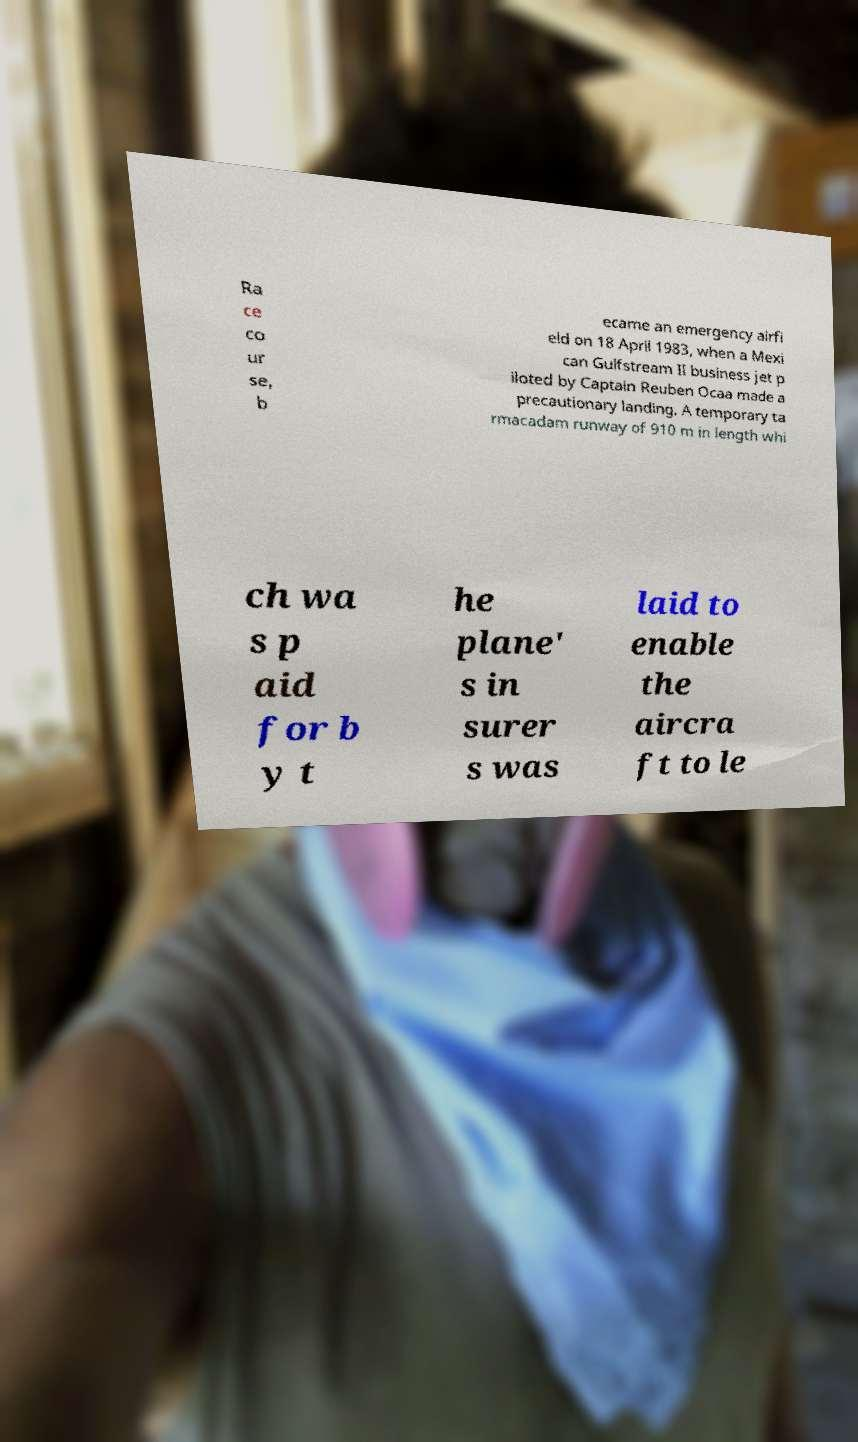What messages or text are displayed in this image? I need them in a readable, typed format. Ra ce co ur se, b ecame an emergency airfi eld on 18 April 1983, when a Mexi can Gulfstream II business jet p iloted by Captain Reuben Ocaa made a precautionary landing. A temporary ta rmacadam runway of 910 m in length whi ch wa s p aid for b y t he plane' s in surer s was laid to enable the aircra ft to le 